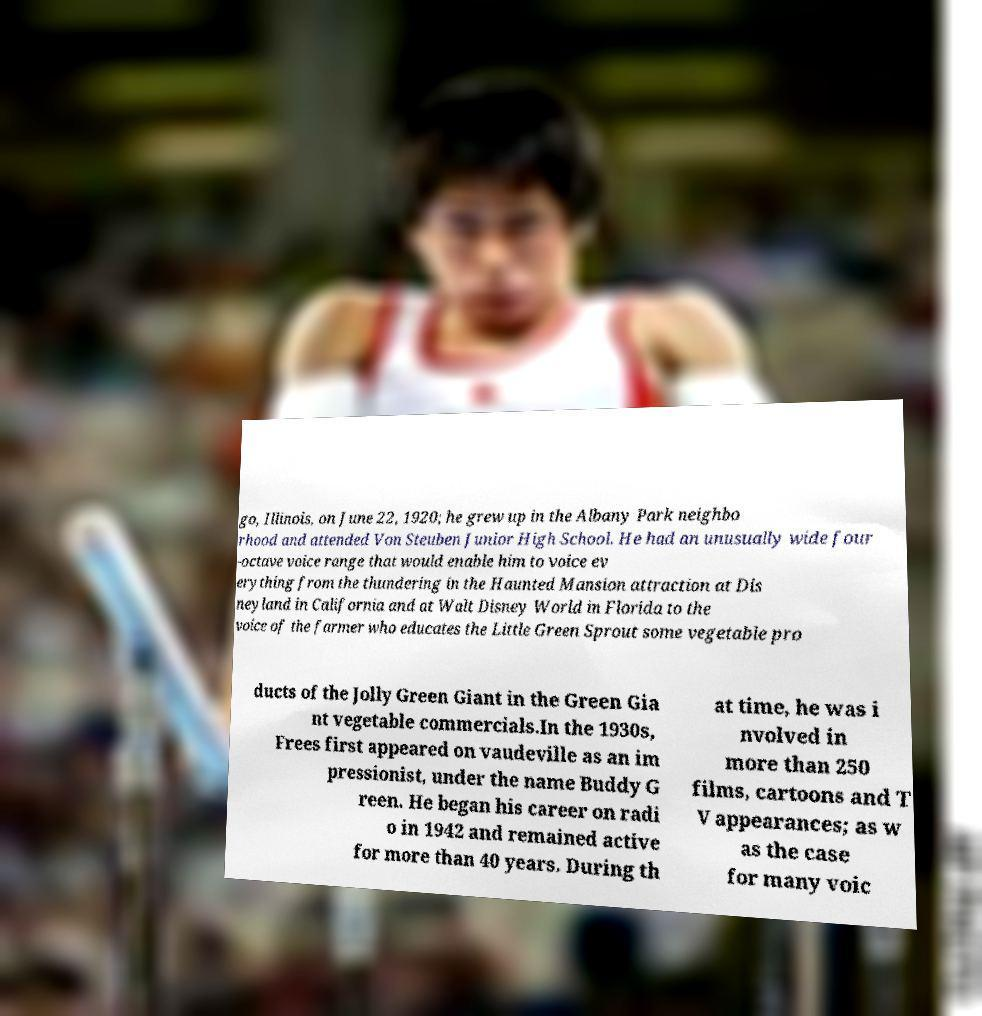Can you accurately transcribe the text from the provided image for me? go, Illinois, on June 22, 1920; he grew up in the Albany Park neighbo rhood and attended Von Steuben Junior High School. He had an unusually wide four -octave voice range that would enable him to voice ev erything from the thundering in the Haunted Mansion attraction at Dis neyland in California and at Walt Disney World in Florida to the voice of the farmer who educates the Little Green Sprout some vegetable pro ducts of the Jolly Green Giant in the Green Gia nt vegetable commercials.In the 1930s, Frees first appeared on vaudeville as an im pressionist, under the name Buddy G reen. He began his career on radi o in 1942 and remained active for more than 40 years. During th at time, he was i nvolved in more than 250 films, cartoons and T V appearances; as w as the case for many voic 